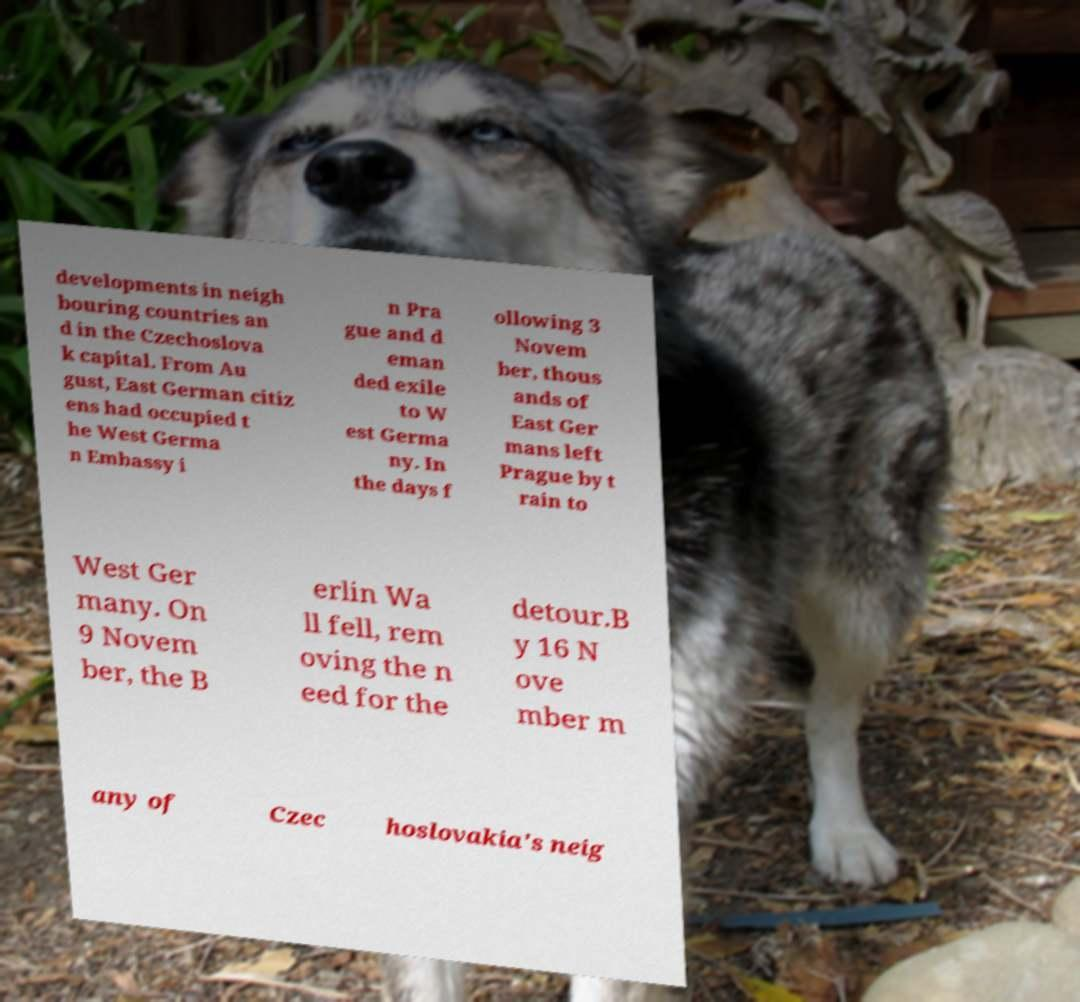There's text embedded in this image that I need extracted. Can you transcribe it verbatim? developments in neigh bouring countries an d in the Czechoslova k capital. From Au gust, East German citiz ens had occupied t he West Germa n Embassy i n Pra gue and d eman ded exile to W est Germa ny. In the days f ollowing 3 Novem ber, thous ands of East Ger mans left Prague by t rain to West Ger many. On 9 Novem ber, the B erlin Wa ll fell, rem oving the n eed for the detour.B y 16 N ove mber m any of Czec hoslovakia's neig 